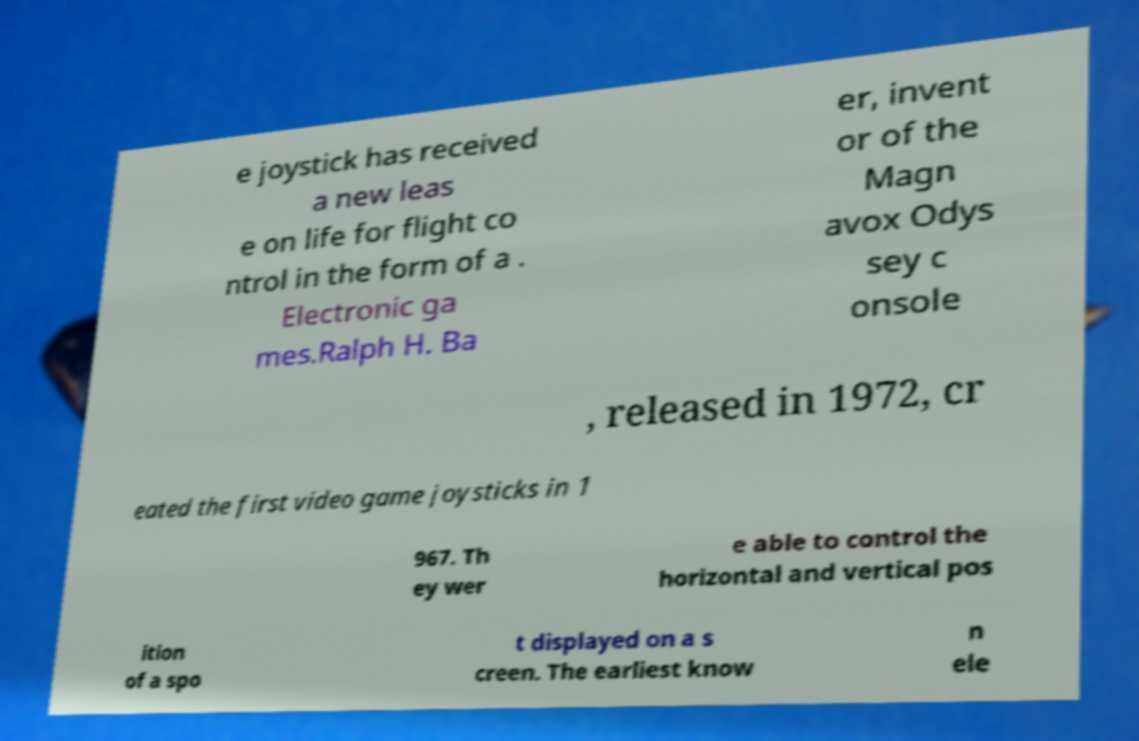Can you accurately transcribe the text from the provided image for me? e joystick has received a new leas e on life for flight co ntrol in the form of a . Electronic ga mes.Ralph H. Ba er, invent or of the Magn avox Odys sey c onsole , released in 1972, cr eated the first video game joysticks in 1 967. Th ey wer e able to control the horizontal and vertical pos ition of a spo t displayed on a s creen. The earliest know n ele 